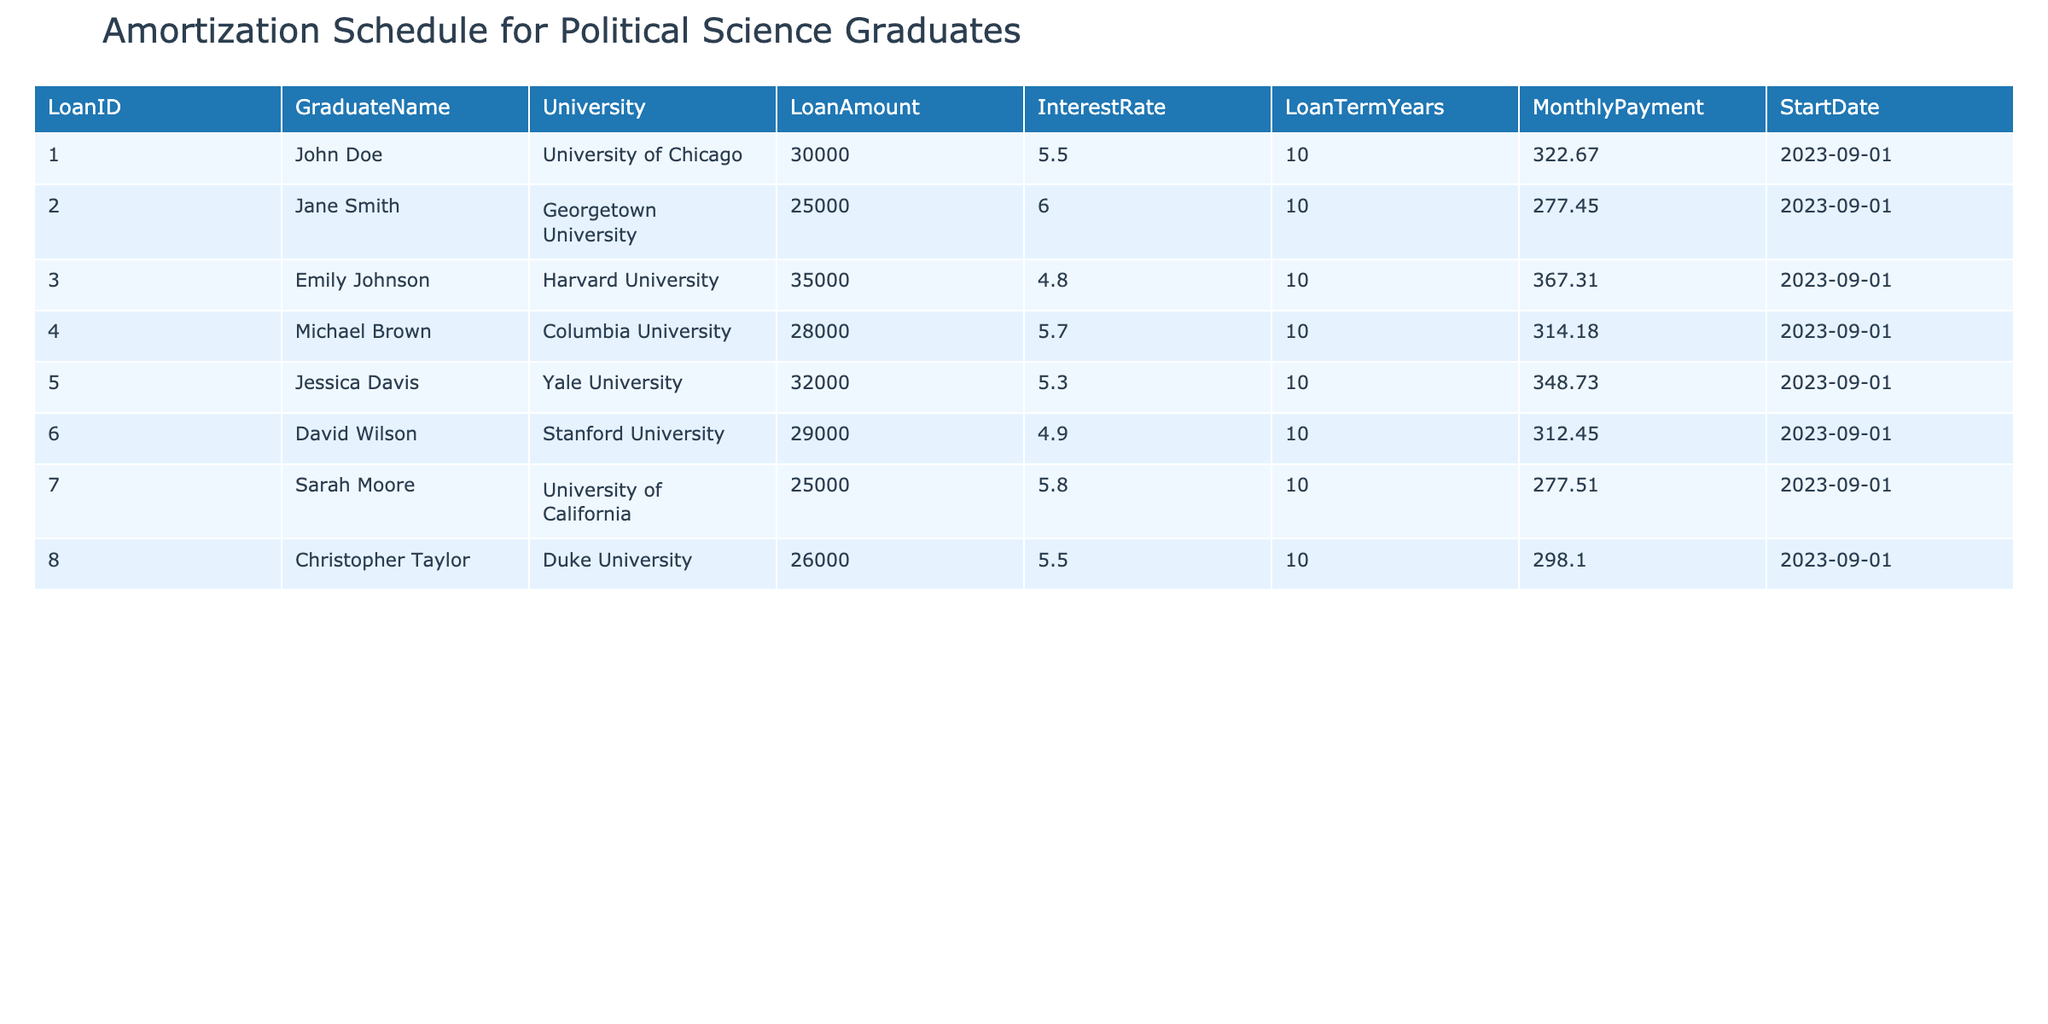What is the Loan Amount for John Doe? The Loan Amount for John Doe is listed in the table under the column "LoanAmount" corresponding to his entry. It shows 30000.
Answer: 30000 Who has the highest monthly payment? To find out who has the highest monthly payment, we should compare the values in the "MonthlyPayment" column. The highest value is 367.31, which corresponds to Emily Johnson.
Answer: Emily Johnson What is the total Loan Amount for all graduates? We need to sum up all values in the "LoanAmount" column. The calculation is (30000 + 25000 + 35000 + 28000 + 32000 + 29000 + 25000 + 26000) = 228000.
Answer: 228000 Is Sarah Moore's Loan Amount greater than Jessica Davis's Loan Amount? By comparing the "LoanAmount" values, Sarah Moore has 25000 and Jessica Davis has 32000. Since 25000 is not greater than 32000, the statement is false.
Answer: No Which graduate has the lowest interest rate, and what is that rate? We need to scan the "InterestRate" column to identify the lowest value. The interest rates are 5.5, 6.0, 4.8, 5.7, 5.3, 4.9, 5.8, and 5.5. The lowest rate is 4.8, which corresponds to Emily Johnson.
Answer: Emily Johnson, 4.8 What is the average interest rate of all loans? To calculate the average, we sum all the values in the "InterestRate" column: (5.5 + 6.0 + 4.8 + 5.7 + 5.3 + 4.9 + 5.8 + 5.5) = 43.5, then divide by the number of graduates (8), yielding 43.5/8 = 5.4375.
Answer: 5.4375 How many graduates have loan amounts of 30,000 or more? By counting the values in the "LoanAmount" column that are 30,000 or greater, we find John Doe (30000), Emily Johnson (35000), Jessica Davis (32000), and David Wilson (29000). Thus, the count is 4.
Answer: 4 Is the average monthly payment greater than 300? To find the average monthly payment, we sum the "MonthlyPayment" values: (322.67 + 277.45 + 367.31 + 314.18 + 348.73 + 312.45 + 277.51 + 298.10) = 2318.4, then divide by 8, yielding 2318.4/8 = 289.8. Therefore, it is not greater than 300.
Answer: No 